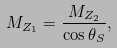<formula> <loc_0><loc_0><loc_500><loc_500>M _ { Z _ { 1 } } = \frac { M _ { Z _ { 2 } } } { \cos \theta _ { S } } ,</formula> 